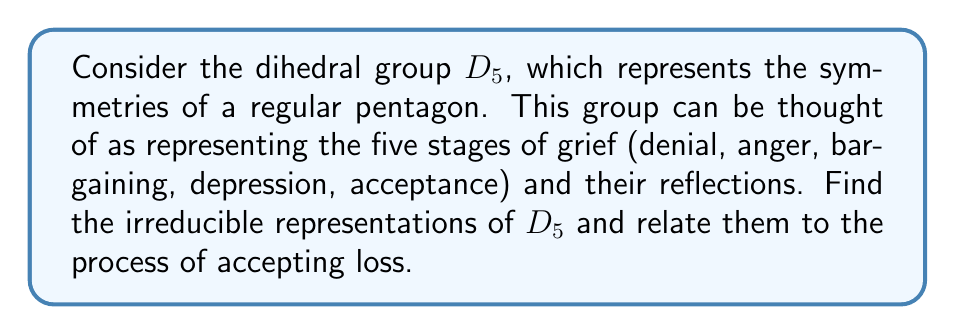Show me your answer to this math problem. Let's approach this step-by-step:

1) The dihedral group $D_5$ has order 10 and is generated by two elements: $r$ (rotation) and $s$ (reflection), satisfying $r^5 = s^2 = 1$ and $srs = r^{-1}$.

2) To find the irreducible representations, we need to consider the conjugacy classes of $D_5$:
   - $\{1\}$
   - $\{r, r^4\}$
   - $\{r^2, r^3\}$
   - $\{s, sr, sr^2, sr^3, sr^4\}$

3) The number of irreducible representations equals the number of conjugacy classes, so we expect 4 irreducible representations.

4) We know that $D_5$ has 4 one-dimensional representations:
   - The trivial representation: $\chi_1(g) = 1$ for all $g \in D_5$
   - Three more where $r$ maps to a 5th root of unity and $s$ maps to $\pm 1$

5) The remaining representation must be two-dimensional to satisfy $1^2 + 1^2 + 1^2 + 1^2 + 2^2 = 10$ (the order of the group).

6) This two-dimensional representation can be realized as:
   $$r \mapsto \begin{pmatrix} \cos(2\pi/5) & -\sin(2\pi/5) \\ \sin(2\pi/5) & \cos(2\pi/5) \end{pmatrix}, 
     s \mapsto \begin{pmatrix} 1 & 0 \\ 0 & -1 \end{pmatrix}$$

7) Relating to the stages of grief:
   - The trivial representation could represent complete acceptance, unchanged by any transition.
   - The three other one-dimensional representations might represent different ways of processing grief, with some stages feeling reversed or negated.
   - The two-dimensional representation could represent the complex interplay between different stages, showing how one can move back and forth between them in a cyclical manner.
Answer: $D_5$ has four 1-dimensional irreducible representations and one 2-dimensional irreducible representation, reflecting various aspects of the grief process from stagnation to complex transitions. 